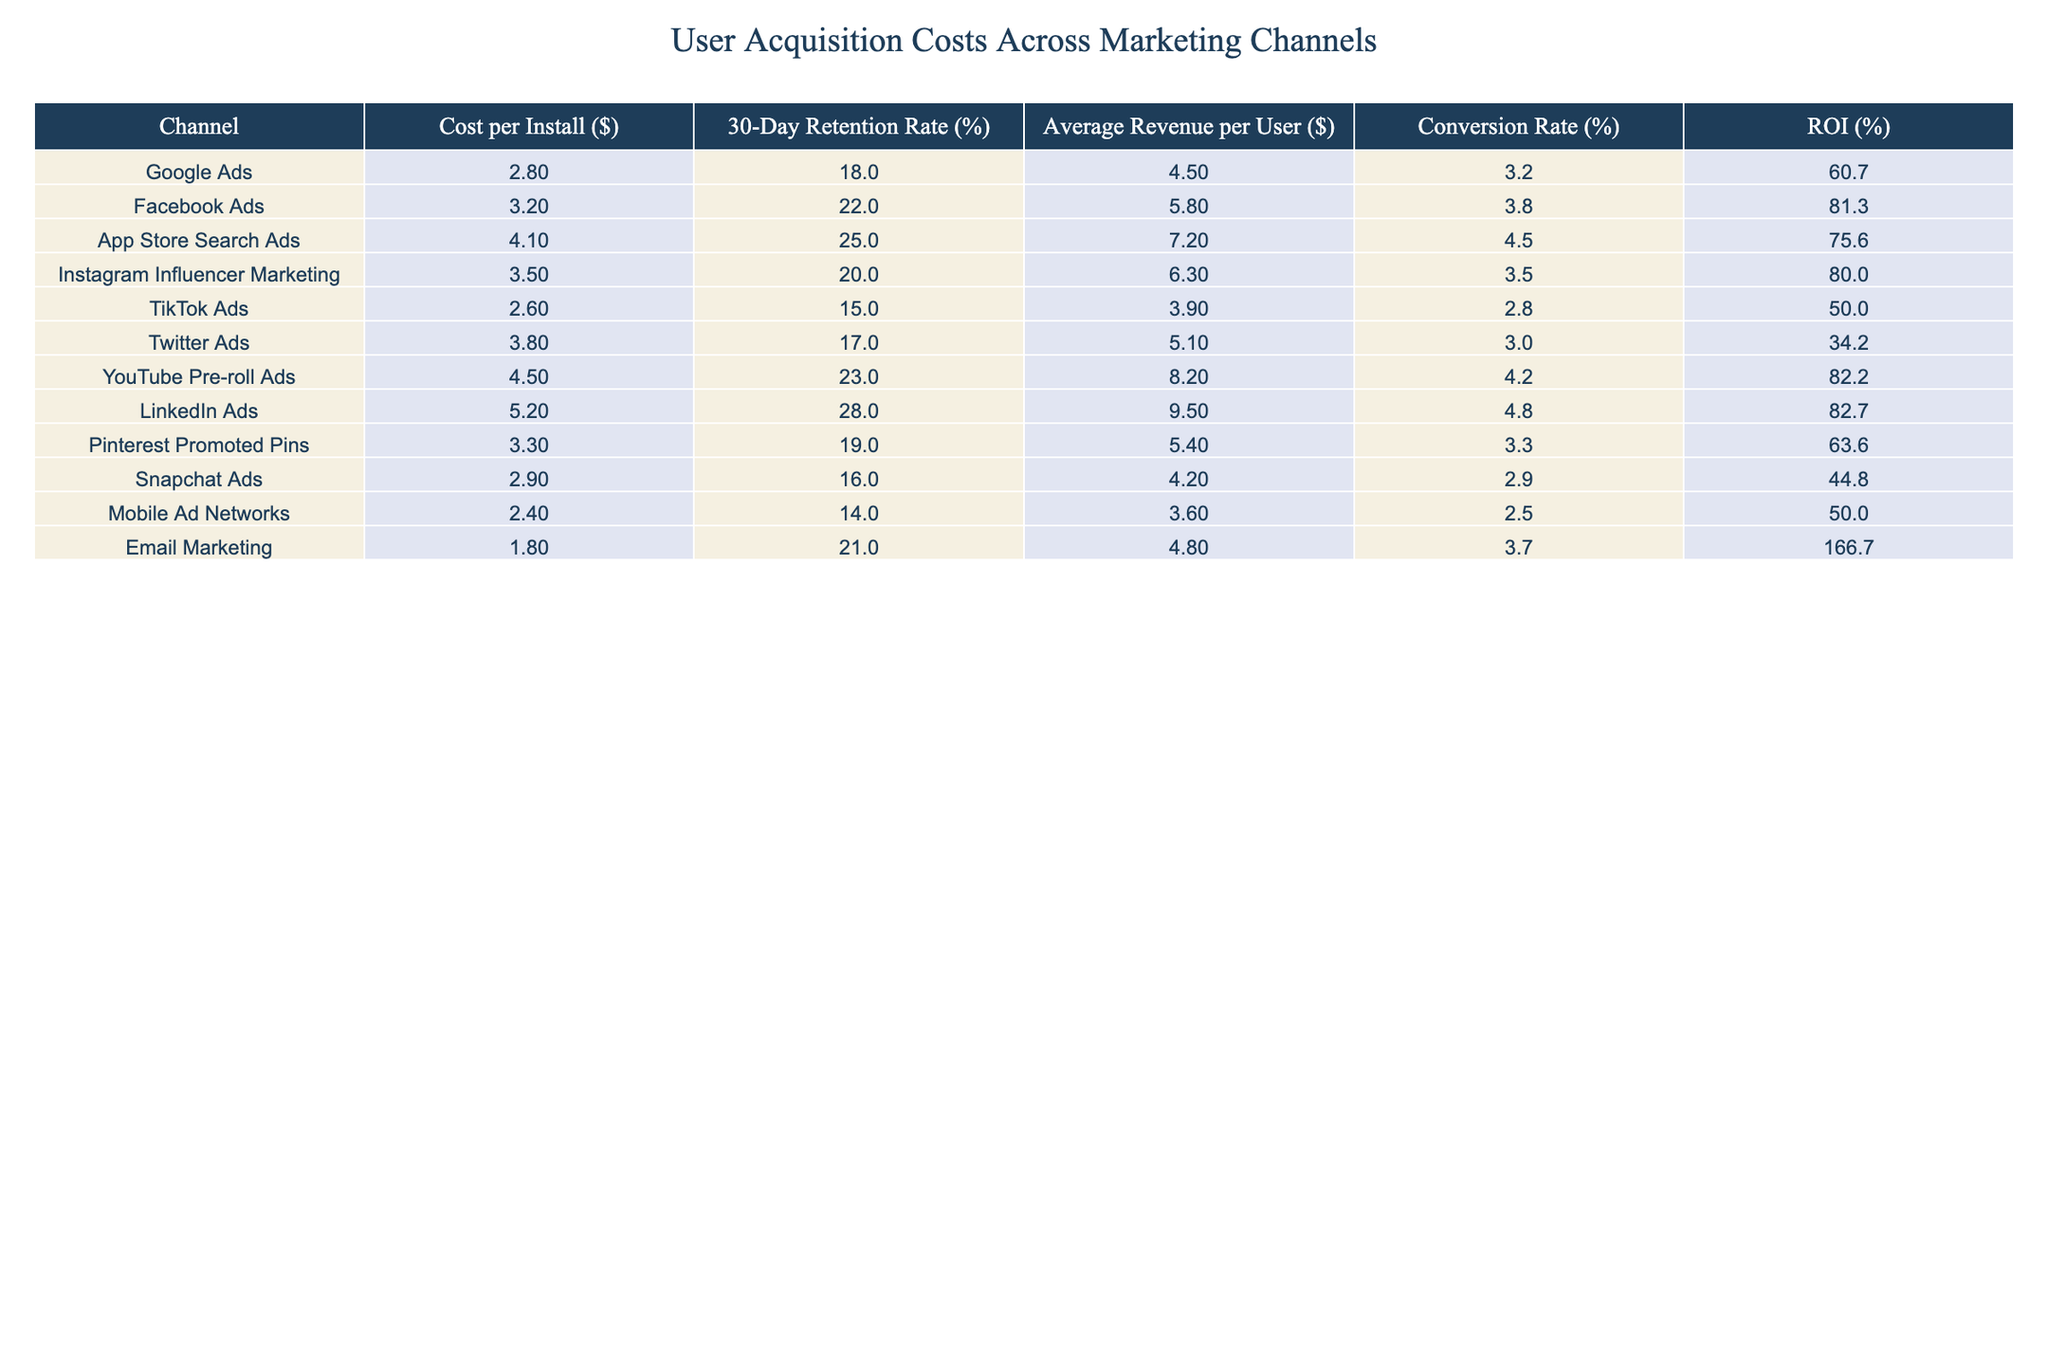What is the cost per install for Facebook Ads? The table indicates that the cost per install for Facebook Ads is $3.20.
Answer: 3.20 Which marketing channel has the highest 30-day retention rate? According to the table, LinkedIn Ads has the highest 30-day retention rate of 28%.
Answer: 28% What is the average revenue per user for TikTok Ads? The table shows that TikTok Ads have an average revenue per user of $3.90.
Answer: 3.90 What is the difference in cost per install between Google Ads and Email Marketing? The cost per install for Google Ads is $2.80 and for Email Marketing is $1.80. Thus, the difference is $2.80 - $1.80 = $1.00.
Answer: 1.00 Is the ROI for Instagram Influencer Marketing greater than that for TikTok Ads? Instagram Influencer Marketing has an ROI of 80.0%, while TikTok Ads have an ROI of 50.0%. Therefore, the statement is true.
Answer: Yes Which marketing channel has the best return on investment, and how is it calculated? To find the best ROI, we can compare all ROIs: Email Marketing has the highest ROI of 166.7%, calculated as (ARPU - CPI) / CPI * 100% where ARPU for Email Marketing is $4.80 and CPI is $1.80.
Answer: Email Marketing What is the average 30-day retention rate across all channels? By summing all the 30-day retention rates (18 + 22 + 25 + 20 + 15 + 17 + 23 + 28 + 19 + 16 + 14 + 21), which totals to  18 + 22 + 25 + 20 + 15 + 17 + 23 + 28 + 19 + 16 + 14 + 21 =  30, then dividing by the number of channels (12) results in an average retention rate of approximately 20.5%.
Answer: 20.5 Which channel offers a higher average revenue per user, Facebook Ads or Instagram Influencer Marketing? Facebook Ads have an average revenue per user of $5.80, while Instagram Influencer Marketing has $6.30. Since $6.30 > $5.80, the statement is true.
Answer: Yes Is Mobile Ad Networks the least expensive option based on cost per install? Comparing the cost per installs, Mobile Ad Networks has $2.40, which is the lowest among the listed channels. Therefore, the statement is true.
Answer: Yes 